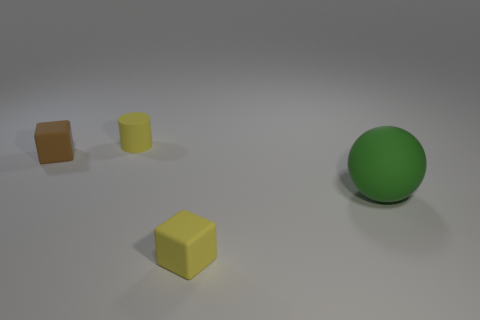Are there any other things that are the same shape as the green thing?
Keep it short and to the point. No. How many small cubes are in front of the yellow matte object behind the green rubber ball?
Ensure brevity in your answer.  2. There is a matte thing that is both behind the yellow block and to the right of the matte cylinder; what is its size?
Offer a very short reply. Large. Is the number of tiny rubber cylinders greater than the number of blocks?
Offer a terse response. No. Are there any large rubber spheres that have the same color as the large thing?
Keep it short and to the point. No. There is a cube in front of the brown block; does it have the same size as the tiny yellow matte cylinder?
Your answer should be very brief. Yes. Is the number of brown blocks less than the number of small purple blocks?
Provide a succinct answer. No. Is there another brown object that has the same material as the brown object?
Your answer should be very brief. No. What shape is the object that is right of the tiny yellow cube?
Offer a very short reply. Sphere. There is a matte cube in front of the big matte ball; does it have the same color as the large thing?
Give a very brief answer. No. 